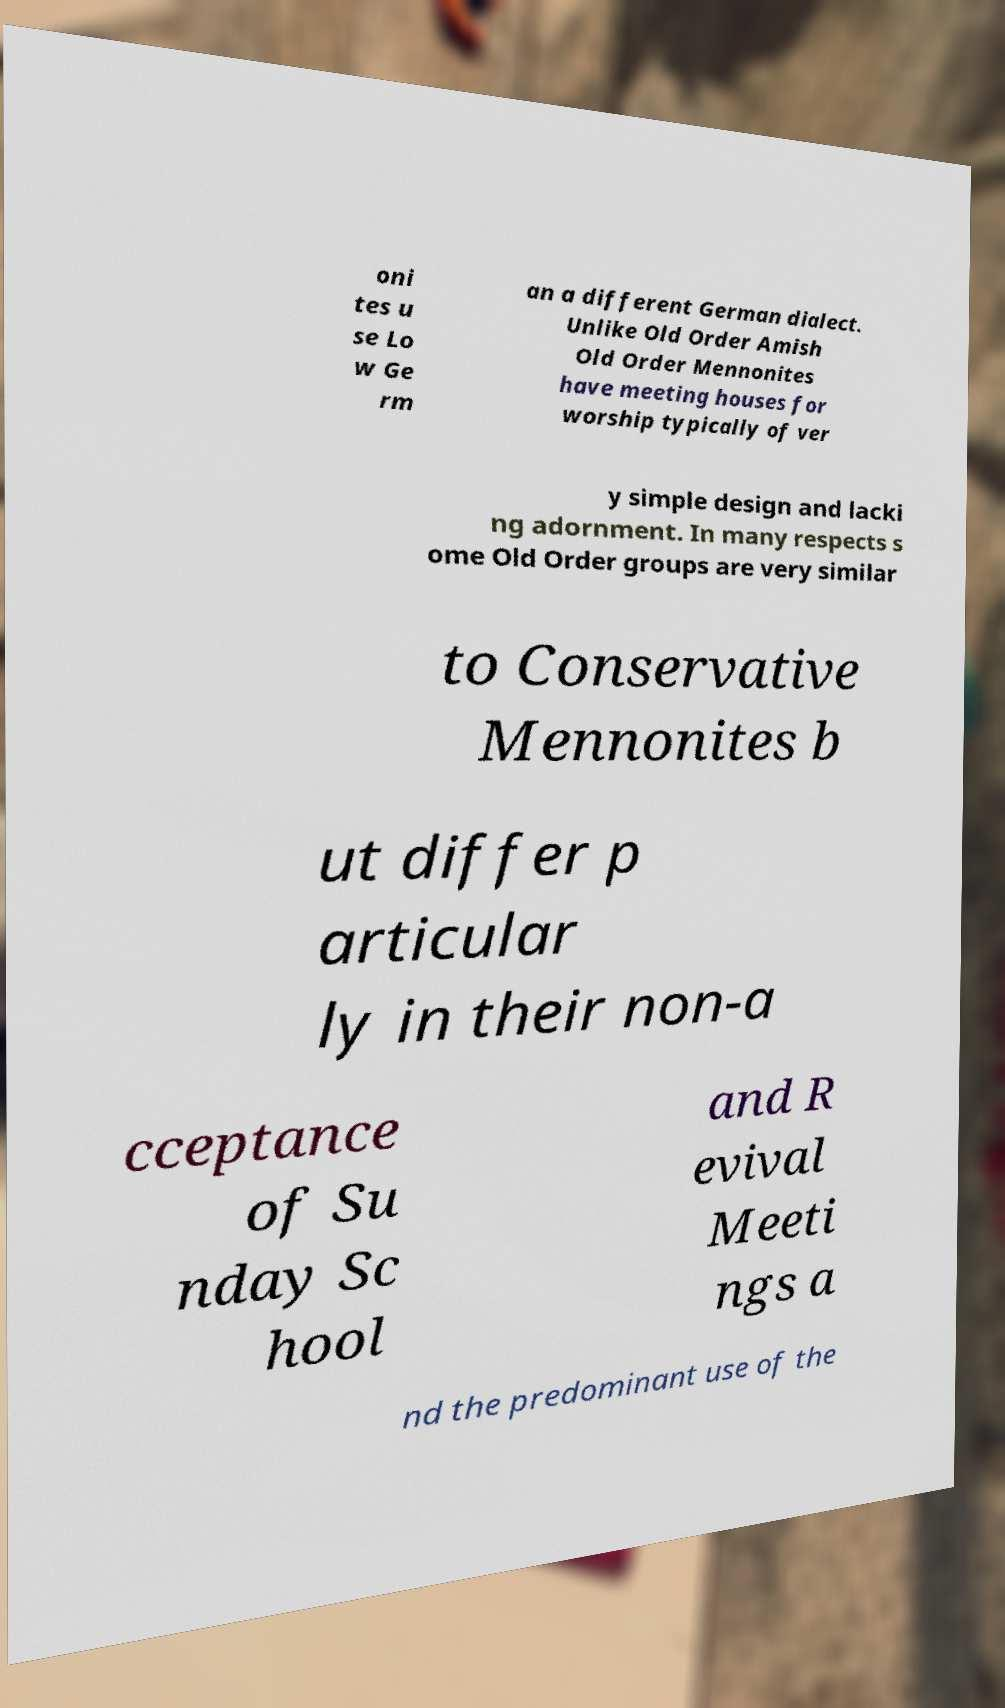Please read and relay the text visible in this image. What does it say? oni tes u se Lo w Ge rm an a different German dialect. Unlike Old Order Amish Old Order Mennonites have meeting houses for worship typically of ver y simple design and lacki ng adornment. In many respects s ome Old Order groups are very similar to Conservative Mennonites b ut differ p articular ly in their non-a cceptance of Su nday Sc hool and R evival Meeti ngs a nd the predominant use of the 